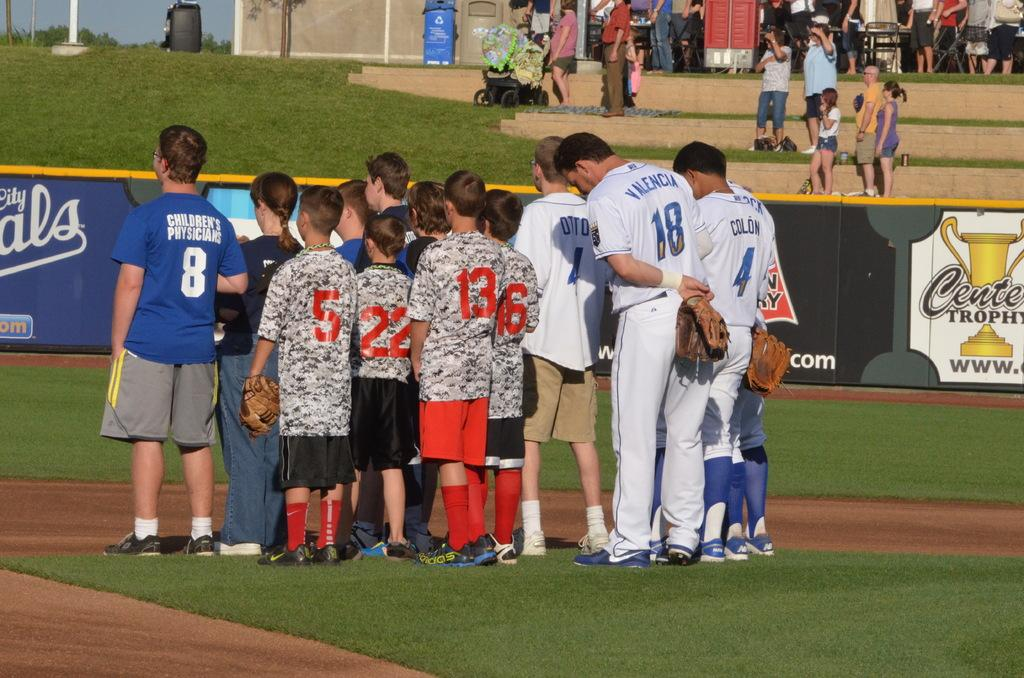Provide a one-sentence caption for the provided image. Baseball player number 4 stands with his back to the camera with other baseball players and children. 